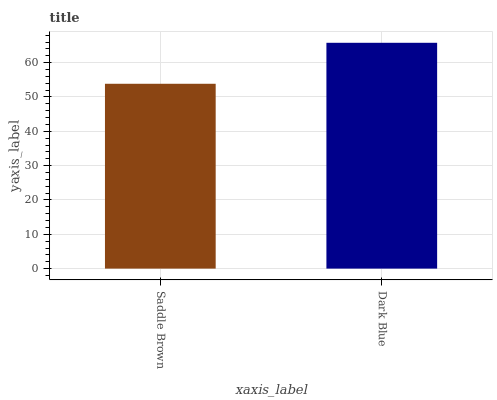Is Saddle Brown the minimum?
Answer yes or no. Yes. Is Dark Blue the maximum?
Answer yes or no. Yes. Is Dark Blue the minimum?
Answer yes or no. No. Is Dark Blue greater than Saddle Brown?
Answer yes or no. Yes. Is Saddle Brown less than Dark Blue?
Answer yes or no. Yes. Is Saddle Brown greater than Dark Blue?
Answer yes or no. No. Is Dark Blue less than Saddle Brown?
Answer yes or no. No. Is Dark Blue the high median?
Answer yes or no. Yes. Is Saddle Brown the low median?
Answer yes or no. Yes. Is Saddle Brown the high median?
Answer yes or no. No. Is Dark Blue the low median?
Answer yes or no. No. 